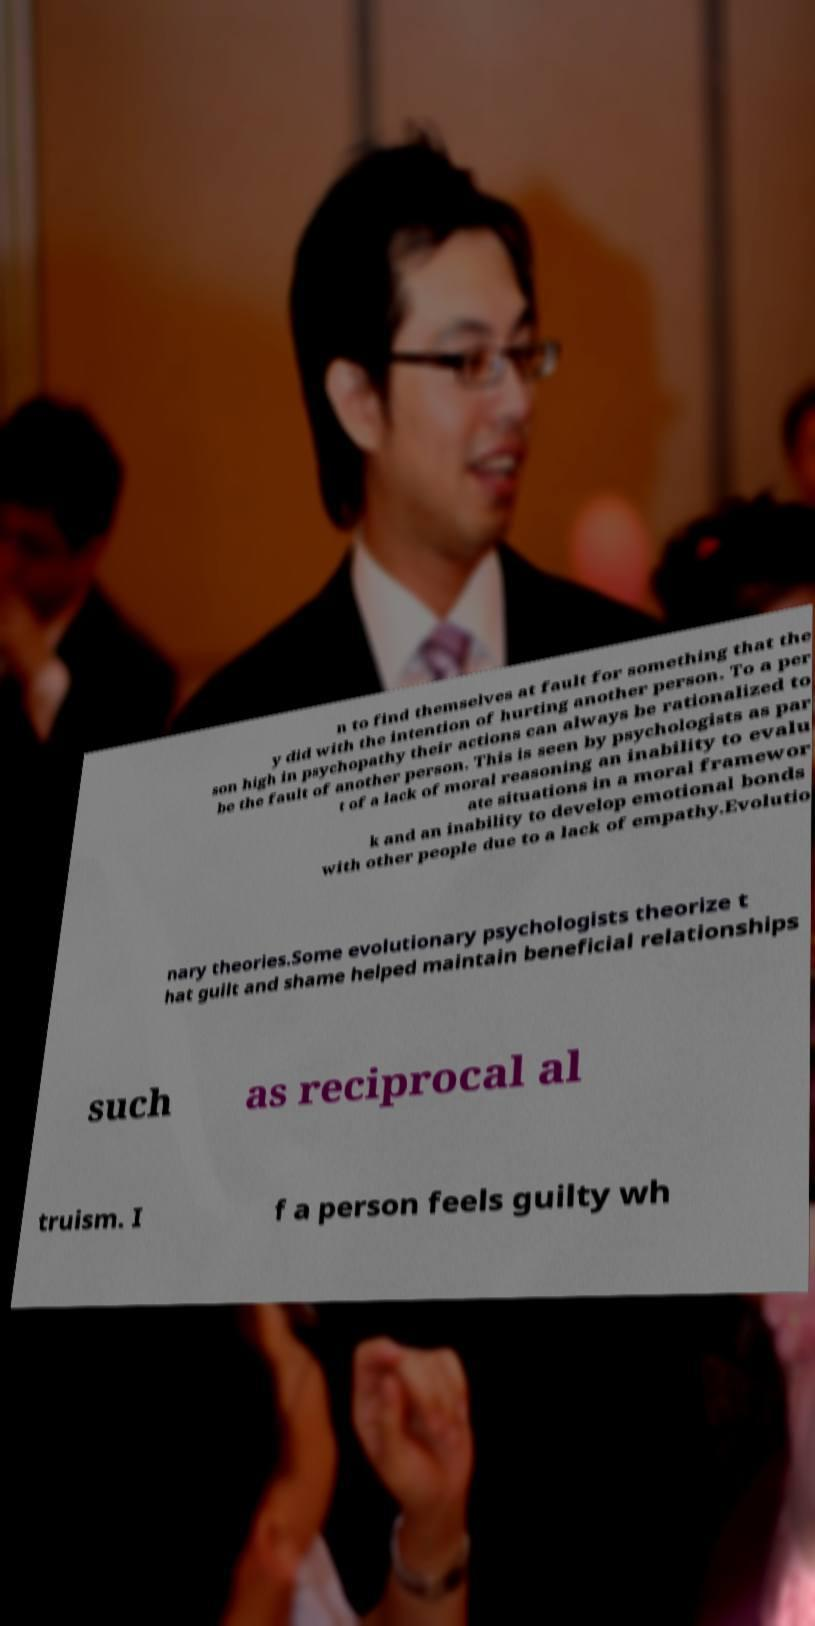Could you extract and type out the text from this image? n to find themselves at fault for something that the y did with the intention of hurting another person. To a per son high in psychopathy their actions can always be rationalized to be the fault of another person. This is seen by psychologists as par t of a lack of moral reasoning an inability to evalu ate situations in a moral framewor k and an inability to develop emotional bonds with other people due to a lack of empathy.Evolutio nary theories.Some evolutionary psychologists theorize t hat guilt and shame helped maintain beneficial relationships such as reciprocal al truism. I f a person feels guilty wh 